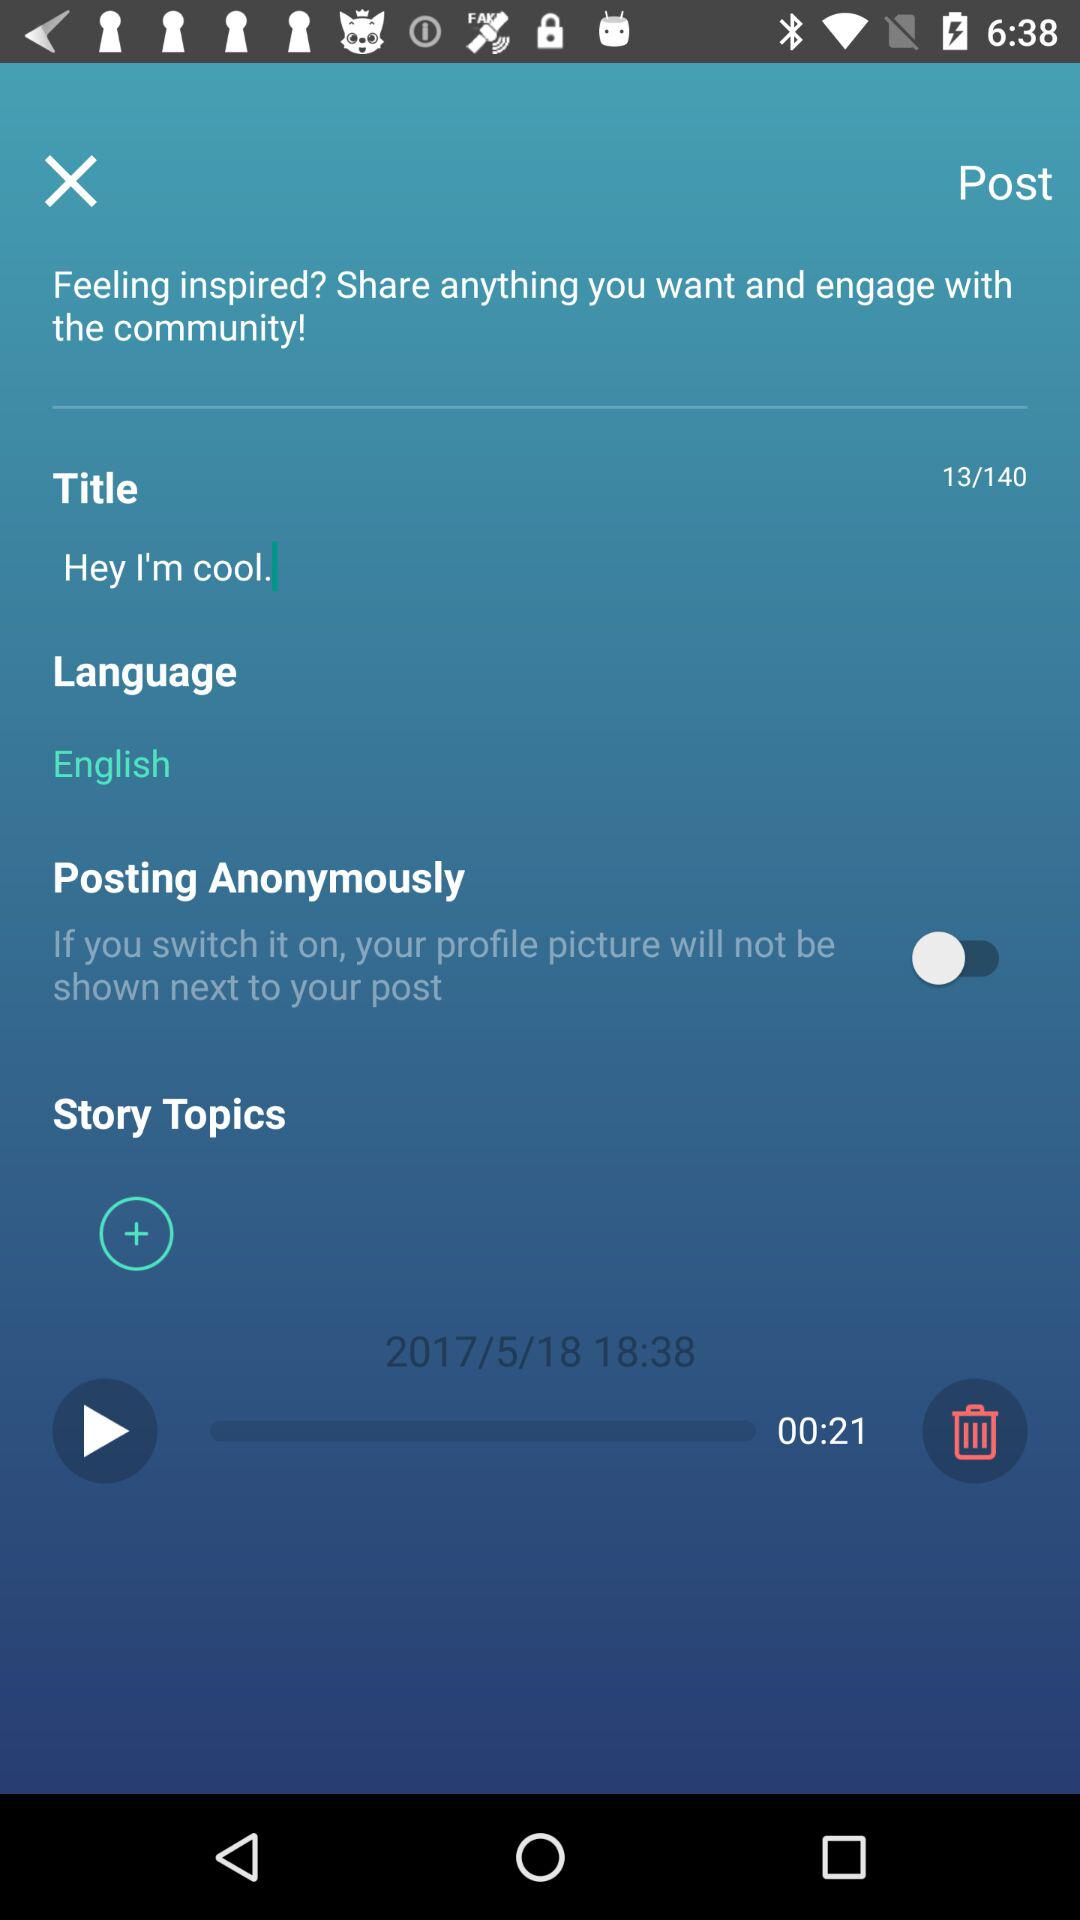How many minutes long is the video?
Answer the question using a single word or phrase. 00:21 